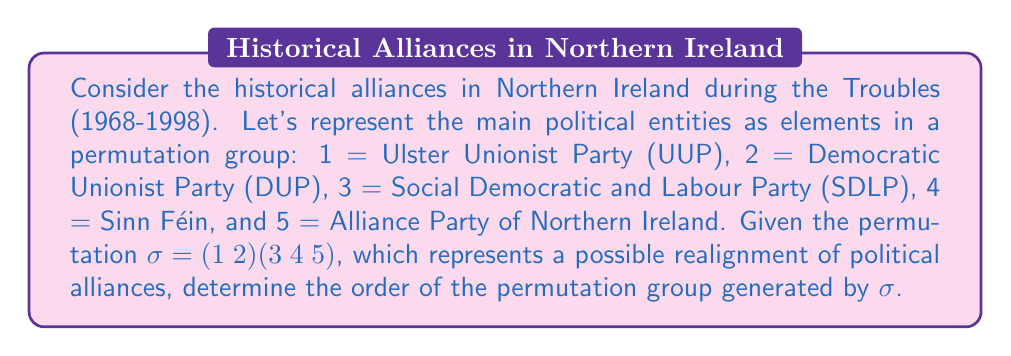Teach me how to tackle this problem. To solve this problem, we need to follow these steps:

1) First, let's understand what the permutation $\sigma = (1 2)(3 4 5)$ means:
   - It's a product of two disjoint cycles: $(1 2)$ and $(3 4 5)$
   - $(1 2)$ swaps 1 and 2 (UUP and DUP)
   - $(3 4 5)$ rotates 3, 4, and 5 (SDLP, Sinn Féin, and Alliance Party)

2) The order of a permutation is the least common multiple (LCM) of the lengths of its disjoint cycles.

3) The length of $(1 2)$ is 2.
   The length of $(3 4 5)$ is 3.

4) Therefore, the order of $\sigma$ is $LCM(2, 3)$.

5) To calculate $LCM(2, 3)$:
   - Prime factorization of 2 is $2^1$
   - Prime factorization of 3 is $3^1$
   - $LCM(2, 3) = 2^1 \times 3^1 = 6$

6) This means that applying $\sigma$ six times will return the group to its original state:
   $\sigma^6 = (1 2)^6 (3 4 5)^6 = e$ (identity permutation)

7) The permutation group generated by $\sigma$ is $\{\sigma^1, \sigma^2, \sigma^3, \sigma^4, \sigma^5, \sigma^6 = e\}$

Therefore, the order of the permutation group generated by $\sigma$ is 6.

This result symbolizes that in this simplified model of Northern Irish politics, it would take 6 "realignments" before the political landscape returns to its original state, reflecting the complex and cyclical nature of alliances in the region's history.
Answer: The order of the permutation group generated by $\sigma$ is 6. 